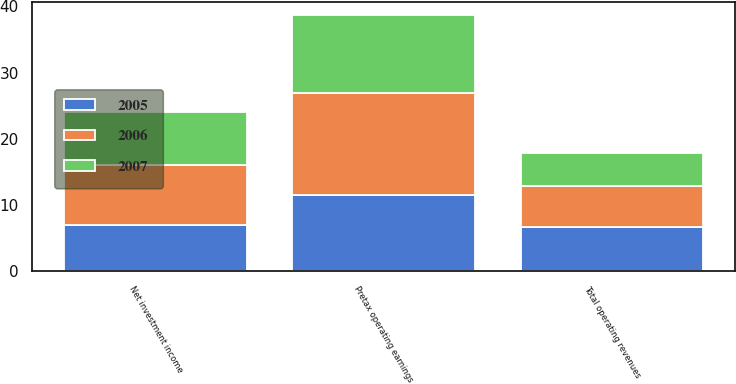Convert chart. <chart><loc_0><loc_0><loc_500><loc_500><stacked_bar_chart><ecel><fcel>Net investment income<fcel>Total operating revenues<fcel>Pretax operating earnings<nl><fcel>2007<fcel>8<fcel>4.9<fcel>11.8<nl><fcel>2006<fcel>9<fcel>6.3<fcel>15.4<nl><fcel>2005<fcel>7<fcel>6.6<fcel>11.5<nl></chart> 